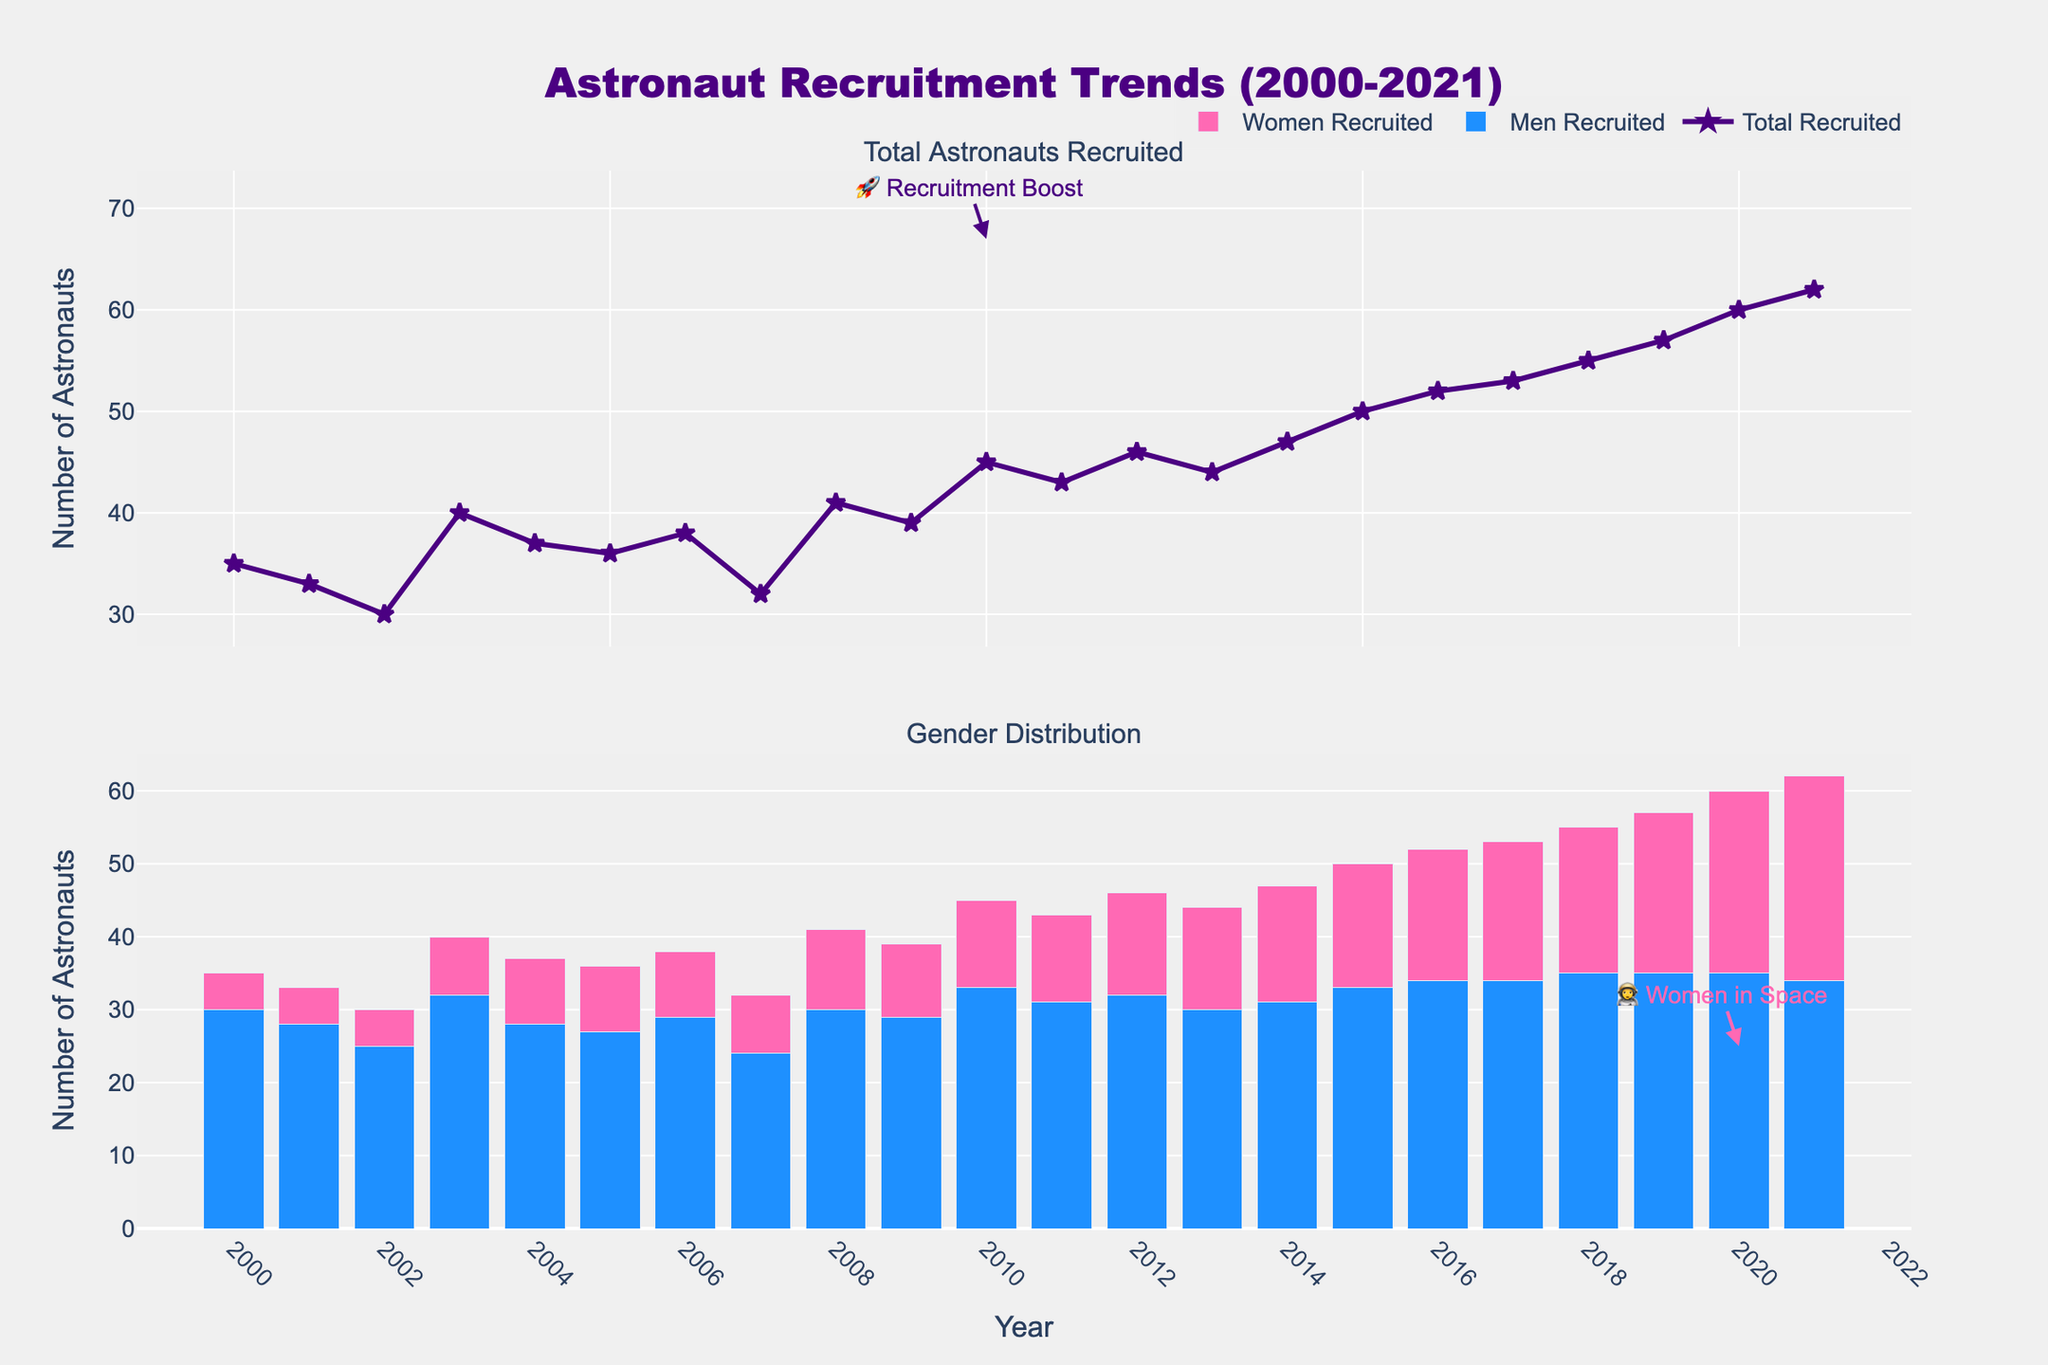What is the overall trend in the total number of astronauts recruited from 2000 to 2021? The overall trend shows an increase in the total number of astronauts recruited over the period. The total number increased from 35 in 2000 to 62 in 2021.
Answer: Increasing How many astronauts were recruited in 2018, and how does it compare to those recruited in 2019? In 2018, 55 astronauts were recruited and in 2019, 57 astronauts were recruited. Comparing the two years, 2 more astronauts were recruited in 2019 than in 2018.
Answer: 2 more in 2019 What is the highest number of women recruited in a single year, and in which year did it occur? The highest number of women recruited in a single year is 28, and it occurred in 2021.
Answer: 28 in 2021 How does the recruitment of men and women compare in the year 2005? In 2005, 27 men were recruited, and 9 women were recruited. Hence, 18 more men were recruited than women.
Answer: 18 more men From 2000 to 2010, did the number of women recruited show an increasing trend, and if so, by how much did it increase? Yes, the number of women recruited increased from 5 in 2000 to 12 in 2010, showing an increase of 7 over the period.
Answer: Increased by 7 Which year shows the largest increase in the total number of astronauts recruited compared to the previous year? The largest increase in the total number of astronauts recruited compared to the previous year occurred from 2019 to 2020, where the number increased by 3 (from 57 to 60).
Answer: 2019 to 2020 In which year did the recruitment of women exceed 20 for the first time? The recruitment of women first exceeded 20 in the year 2019, with 22 women recruited.
Answer: 2019 Is there any year where the number of men recruited is less than the number of women recruited? If so, which year? No, there is no year where the number of men recruited is less than the number of women recruited.
Answer: No Is there a year where the recruitment numbers (men and women combined) reached or exceeded 50 for the first time? Yes, the recruitment numbers reached 50 for the first time in 2015.
Answer: 2015 Considering the second subplot, which gender shows a more consistent increase over the years? The recruitment of women shows a more consistent increase over the years, particularly prominent from 2010 onwards.
Answer: Women 